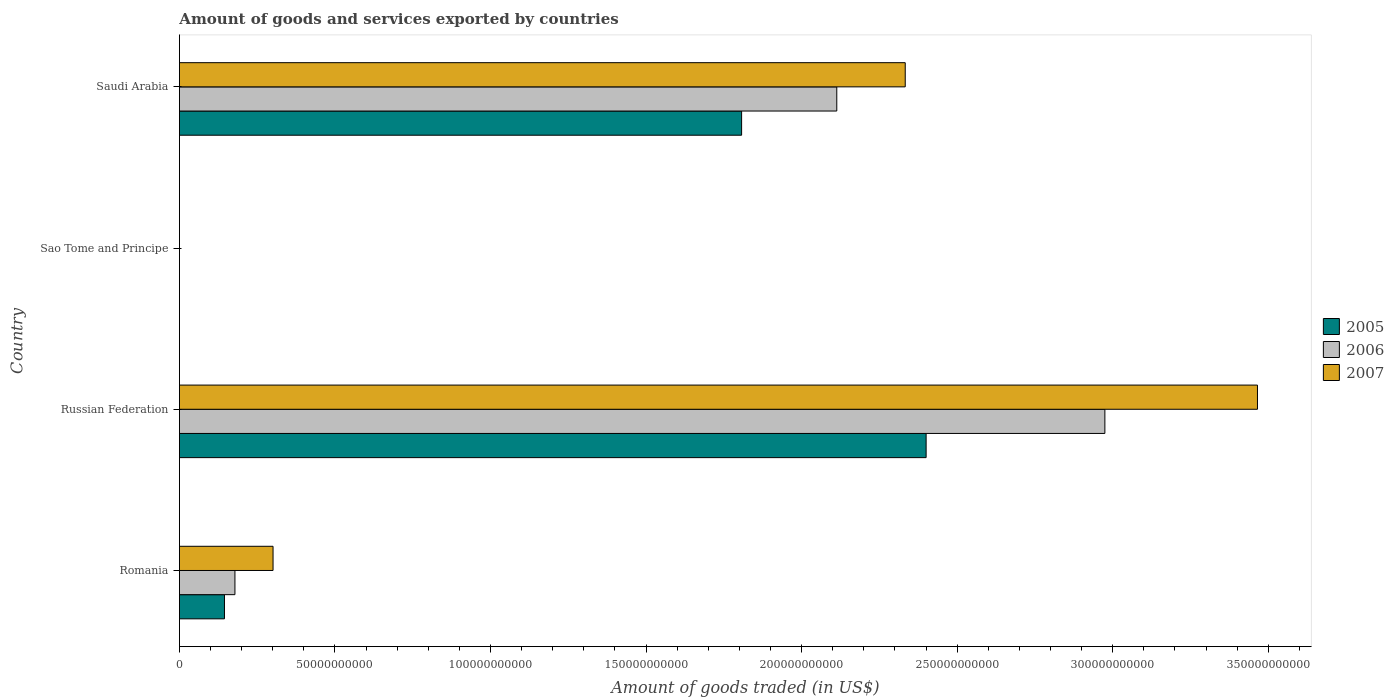How many different coloured bars are there?
Your response must be concise. 3. How many groups of bars are there?
Your answer should be compact. 4. Are the number of bars per tick equal to the number of legend labels?
Offer a terse response. Yes. How many bars are there on the 4th tick from the bottom?
Provide a short and direct response. 3. What is the label of the 2nd group of bars from the top?
Keep it short and to the point. Sao Tome and Principe. What is the total amount of goods and services exported in 2006 in Russian Federation?
Your answer should be very brief. 2.97e+11. Across all countries, what is the maximum total amount of goods and services exported in 2006?
Your response must be concise. 2.97e+11. Across all countries, what is the minimum total amount of goods and services exported in 2006?
Provide a short and direct response. 7.71e+06. In which country was the total amount of goods and services exported in 2006 maximum?
Your response must be concise. Russian Federation. In which country was the total amount of goods and services exported in 2007 minimum?
Offer a terse response. Sao Tome and Principe. What is the total total amount of goods and services exported in 2006 in the graph?
Your response must be concise. 5.27e+11. What is the difference between the total amount of goods and services exported in 2006 in Russian Federation and that in Sao Tome and Principe?
Your answer should be compact. 2.97e+11. What is the difference between the total amount of goods and services exported in 2006 in Saudi Arabia and the total amount of goods and services exported in 2007 in Romania?
Offer a terse response. 1.81e+11. What is the average total amount of goods and services exported in 2006 per country?
Offer a terse response. 1.32e+11. What is the difference between the total amount of goods and services exported in 2006 and total amount of goods and services exported in 2007 in Russian Federation?
Provide a succinct answer. -4.90e+1. What is the ratio of the total amount of goods and services exported in 2005 in Romania to that in Sao Tome and Principe?
Your answer should be very brief. 2132.94. Is the total amount of goods and services exported in 2006 in Romania less than that in Russian Federation?
Your response must be concise. Yes. What is the difference between the highest and the second highest total amount of goods and services exported in 2006?
Make the answer very short. 8.62e+1. What is the difference between the highest and the lowest total amount of goods and services exported in 2006?
Give a very brief answer. 2.97e+11. In how many countries, is the total amount of goods and services exported in 2007 greater than the average total amount of goods and services exported in 2007 taken over all countries?
Offer a very short reply. 2. Is it the case that in every country, the sum of the total amount of goods and services exported in 2007 and total amount of goods and services exported in 2006 is greater than the total amount of goods and services exported in 2005?
Provide a succinct answer. Yes. What is the difference between two consecutive major ticks on the X-axis?
Provide a short and direct response. 5.00e+1. Does the graph contain grids?
Offer a very short reply. No. Where does the legend appear in the graph?
Make the answer very short. Center right. What is the title of the graph?
Ensure brevity in your answer.  Amount of goods and services exported by countries. What is the label or title of the X-axis?
Offer a terse response. Amount of goods traded (in US$). What is the Amount of goods traded (in US$) of 2005 in Romania?
Provide a succinct answer. 1.45e+1. What is the Amount of goods traded (in US$) of 2006 in Romania?
Offer a very short reply. 1.78e+1. What is the Amount of goods traded (in US$) in 2007 in Romania?
Offer a very short reply. 3.01e+1. What is the Amount of goods traded (in US$) in 2005 in Russian Federation?
Keep it short and to the point. 2.40e+11. What is the Amount of goods traded (in US$) of 2006 in Russian Federation?
Provide a short and direct response. 2.97e+11. What is the Amount of goods traded (in US$) of 2007 in Russian Federation?
Provide a short and direct response. 3.47e+11. What is the Amount of goods traded (in US$) in 2005 in Sao Tome and Principe?
Your answer should be compact. 6.79e+06. What is the Amount of goods traded (in US$) of 2006 in Sao Tome and Principe?
Provide a succinct answer. 7.71e+06. What is the Amount of goods traded (in US$) in 2007 in Sao Tome and Principe?
Give a very brief answer. 6.81e+06. What is the Amount of goods traded (in US$) of 2005 in Saudi Arabia?
Offer a terse response. 1.81e+11. What is the Amount of goods traded (in US$) in 2006 in Saudi Arabia?
Keep it short and to the point. 2.11e+11. What is the Amount of goods traded (in US$) in 2007 in Saudi Arabia?
Make the answer very short. 2.33e+11. Across all countries, what is the maximum Amount of goods traded (in US$) of 2005?
Give a very brief answer. 2.40e+11. Across all countries, what is the maximum Amount of goods traded (in US$) of 2006?
Make the answer very short. 2.97e+11. Across all countries, what is the maximum Amount of goods traded (in US$) in 2007?
Provide a succinct answer. 3.47e+11. Across all countries, what is the minimum Amount of goods traded (in US$) in 2005?
Make the answer very short. 6.79e+06. Across all countries, what is the minimum Amount of goods traded (in US$) of 2006?
Provide a succinct answer. 7.71e+06. Across all countries, what is the minimum Amount of goods traded (in US$) in 2007?
Keep it short and to the point. 6.81e+06. What is the total Amount of goods traded (in US$) in 2005 in the graph?
Offer a very short reply. 4.35e+11. What is the total Amount of goods traded (in US$) of 2006 in the graph?
Give a very brief answer. 5.27e+11. What is the total Amount of goods traded (in US$) in 2007 in the graph?
Make the answer very short. 6.10e+11. What is the difference between the Amount of goods traded (in US$) of 2005 in Romania and that in Russian Federation?
Provide a succinct answer. -2.26e+11. What is the difference between the Amount of goods traded (in US$) in 2006 in Romania and that in Russian Federation?
Provide a succinct answer. -2.80e+11. What is the difference between the Amount of goods traded (in US$) of 2007 in Romania and that in Russian Federation?
Provide a short and direct response. -3.16e+11. What is the difference between the Amount of goods traded (in US$) of 2005 in Romania and that in Sao Tome and Principe?
Make the answer very short. 1.45e+1. What is the difference between the Amount of goods traded (in US$) in 2006 in Romania and that in Sao Tome and Principe?
Provide a succinct answer. 1.78e+1. What is the difference between the Amount of goods traded (in US$) of 2007 in Romania and that in Sao Tome and Principe?
Provide a short and direct response. 3.01e+1. What is the difference between the Amount of goods traded (in US$) in 2005 in Romania and that in Saudi Arabia?
Your answer should be compact. -1.66e+11. What is the difference between the Amount of goods traded (in US$) of 2006 in Romania and that in Saudi Arabia?
Give a very brief answer. -1.93e+11. What is the difference between the Amount of goods traded (in US$) in 2007 in Romania and that in Saudi Arabia?
Offer a very short reply. -2.03e+11. What is the difference between the Amount of goods traded (in US$) of 2005 in Russian Federation and that in Sao Tome and Principe?
Keep it short and to the point. 2.40e+11. What is the difference between the Amount of goods traded (in US$) of 2006 in Russian Federation and that in Sao Tome and Principe?
Ensure brevity in your answer.  2.97e+11. What is the difference between the Amount of goods traded (in US$) in 2007 in Russian Federation and that in Sao Tome and Principe?
Keep it short and to the point. 3.47e+11. What is the difference between the Amount of goods traded (in US$) in 2005 in Russian Federation and that in Saudi Arabia?
Provide a short and direct response. 5.93e+1. What is the difference between the Amount of goods traded (in US$) of 2006 in Russian Federation and that in Saudi Arabia?
Ensure brevity in your answer.  8.62e+1. What is the difference between the Amount of goods traded (in US$) in 2007 in Russian Federation and that in Saudi Arabia?
Provide a short and direct response. 1.13e+11. What is the difference between the Amount of goods traded (in US$) of 2005 in Sao Tome and Principe and that in Saudi Arabia?
Offer a very short reply. -1.81e+11. What is the difference between the Amount of goods traded (in US$) in 2006 in Sao Tome and Principe and that in Saudi Arabia?
Your answer should be compact. -2.11e+11. What is the difference between the Amount of goods traded (in US$) of 2007 in Sao Tome and Principe and that in Saudi Arabia?
Ensure brevity in your answer.  -2.33e+11. What is the difference between the Amount of goods traded (in US$) of 2005 in Romania and the Amount of goods traded (in US$) of 2006 in Russian Federation?
Make the answer very short. -2.83e+11. What is the difference between the Amount of goods traded (in US$) in 2005 in Romania and the Amount of goods traded (in US$) in 2007 in Russian Federation?
Your answer should be compact. -3.32e+11. What is the difference between the Amount of goods traded (in US$) of 2006 in Romania and the Amount of goods traded (in US$) of 2007 in Russian Federation?
Make the answer very short. -3.29e+11. What is the difference between the Amount of goods traded (in US$) in 2005 in Romania and the Amount of goods traded (in US$) in 2006 in Sao Tome and Principe?
Keep it short and to the point. 1.45e+1. What is the difference between the Amount of goods traded (in US$) in 2005 in Romania and the Amount of goods traded (in US$) in 2007 in Sao Tome and Principe?
Provide a succinct answer. 1.45e+1. What is the difference between the Amount of goods traded (in US$) of 2006 in Romania and the Amount of goods traded (in US$) of 2007 in Sao Tome and Principe?
Offer a very short reply. 1.78e+1. What is the difference between the Amount of goods traded (in US$) in 2005 in Romania and the Amount of goods traded (in US$) in 2006 in Saudi Arabia?
Provide a succinct answer. -1.97e+11. What is the difference between the Amount of goods traded (in US$) in 2005 in Romania and the Amount of goods traded (in US$) in 2007 in Saudi Arabia?
Keep it short and to the point. -2.19e+11. What is the difference between the Amount of goods traded (in US$) in 2006 in Romania and the Amount of goods traded (in US$) in 2007 in Saudi Arabia?
Make the answer very short. -2.15e+11. What is the difference between the Amount of goods traded (in US$) in 2005 in Russian Federation and the Amount of goods traded (in US$) in 2006 in Sao Tome and Principe?
Provide a short and direct response. 2.40e+11. What is the difference between the Amount of goods traded (in US$) of 2005 in Russian Federation and the Amount of goods traded (in US$) of 2007 in Sao Tome and Principe?
Keep it short and to the point. 2.40e+11. What is the difference between the Amount of goods traded (in US$) of 2006 in Russian Federation and the Amount of goods traded (in US$) of 2007 in Sao Tome and Principe?
Provide a succinct answer. 2.97e+11. What is the difference between the Amount of goods traded (in US$) in 2005 in Russian Federation and the Amount of goods traded (in US$) in 2006 in Saudi Arabia?
Ensure brevity in your answer.  2.87e+1. What is the difference between the Amount of goods traded (in US$) in 2005 in Russian Federation and the Amount of goods traded (in US$) in 2007 in Saudi Arabia?
Provide a succinct answer. 6.71e+09. What is the difference between the Amount of goods traded (in US$) in 2006 in Russian Federation and the Amount of goods traded (in US$) in 2007 in Saudi Arabia?
Offer a very short reply. 6.42e+1. What is the difference between the Amount of goods traded (in US$) in 2005 in Sao Tome and Principe and the Amount of goods traded (in US$) in 2006 in Saudi Arabia?
Ensure brevity in your answer.  -2.11e+11. What is the difference between the Amount of goods traded (in US$) in 2005 in Sao Tome and Principe and the Amount of goods traded (in US$) in 2007 in Saudi Arabia?
Your answer should be very brief. -2.33e+11. What is the difference between the Amount of goods traded (in US$) of 2006 in Sao Tome and Principe and the Amount of goods traded (in US$) of 2007 in Saudi Arabia?
Offer a terse response. -2.33e+11. What is the average Amount of goods traded (in US$) of 2005 per country?
Make the answer very short. 1.09e+11. What is the average Amount of goods traded (in US$) in 2006 per country?
Offer a terse response. 1.32e+11. What is the average Amount of goods traded (in US$) in 2007 per country?
Your answer should be compact. 1.52e+11. What is the difference between the Amount of goods traded (in US$) of 2005 and Amount of goods traded (in US$) of 2006 in Romania?
Keep it short and to the point. -3.36e+09. What is the difference between the Amount of goods traded (in US$) of 2005 and Amount of goods traded (in US$) of 2007 in Romania?
Ensure brevity in your answer.  -1.56e+1. What is the difference between the Amount of goods traded (in US$) of 2006 and Amount of goods traded (in US$) of 2007 in Romania?
Your response must be concise. -1.23e+1. What is the difference between the Amount of goods traded (in US$) in 2005 and Amount of goods traded (in US$) in 2006 in Russian Federation?
Make the answer very short. -5.75e+1. What is the difference between the Amount of goods traded (in US$) of 2005 and Amount of goods traded (in US$) of 2007 in Russian Federation?
Your response must be concise. -1.07e+11. What is the difference between the Amount of goods traded (in US$) in 2006 and Amount of goods traded (in US$) in 2007 in Russian Federation?
Provide a succinct answer. -4.90e+1. What is the difference between the Amount of goods traded (in US$) of 2005 and Amount of goods traded (in US$) of 2006 in Sao Tome and Principe?
Provide a succinct answer. -9.20e+05. What is the difference between the Amount of goods traded (in US$) of 2005 and Amount of goods traded (in US$) of 2007 in Sao Tome and Principe?
Provide a short and direct response. -1.96e+04. What is the difference between the Amount of goods traded (in US$) in 2006 and Amount of goods traded (in US$) in 2007 in Sao Tome and Principe?
Give a very brief answer. 9.00e+05. What is the difference between the Amount of goods traded (in US$) in 2005 and Amount of goods traded (in US$) in 2006 in Saudi Arabia?
Offer a very short reply. -3.06e+1. What is the difference between the Amount of goods traded (in US$) in 2005 and Amount of goods traded (in US$) in 2007 in Saudi Arabia?
Your answer should be compact. -5.26e+1. What is the difference between the Amount of goods traded (in US$) in 2006 and Amount of goods traded (in US$) in 2007 in Saudi Arabia?
Your response must be concise. -2.20e+1. What is the ratio of the Amount of goods traded (in US$) in 2005 in Romania to that in Russian Federation?
Ensure brevity in your answer.  0.06. What is the ratio of the Amount of goods traded (in US$) of 2007 in Romania to that in Russian Federation?
Ensure brevity in your answer.  0.09. What is the ratio of the Amount of goods traded (in US$) in 2005 in Romania to that in Sao Tome and Principe?
Provide a short and direct response. 2132.94. What is the ratio of the Amount of goods traded (in US$) in 2006 in Romania to that in Sao Tome and Principe?
Your answer should be compact. 2314.31. What is the ratio of the Amount of goods traded (in US$) of 2007 in Romania to that in Sao Tome and Principe?
Your answer should be very brief. 4419.4. What is the ratio of the Amount of goods traded (in US$) of 2005 in Romania to that in Saudi Arabia?
Provide a succinct answer. 0.08. What is the ratio of the Amount of goods traded (in US$) of 2006 in Romania to that in Saudi Arabia?
Provide a succinct answer. 0.08. What is the ratio of the Amount of goods traded (in US$) in 2007 in Romania to that in Saudi Arabia?
Keep it short and to the point. 0.13. What is the ratio of the Amount of goods traded (in US$) of 2005 in Russian Federation to that in Sao Tome and Principe?
Offer a very short reply. 3.53e+04. What is the ratio of the Amount of goods traded (in US$) in 2006 in Russian Federation to that in Sao Tome and Principe?
Provide a succinct answer. 3.86e+04. What is the ratio of the Amount of goods traded (in US$) in 2007 in Russian Federation to that in Sao Tome and Principe?
Offer a very short reply. 5.09e+04. What is the ratio of the Amount of goods traded (in US$) in 2005 in Russian Federation to that in Saudi Arabia?
Your answer should be compact. 1.33. What is the ratio of the Amount of goods traded (in US$) in 2006 in Russian Federation to that in Saudi Arabia?
Ensure brevity in your answer.  1.41. What is the ratio of the Amount of goods traded (in US$) in 2007 in Russian Federation to that in Saudi Arabia?
Your answer should be very brief. 1.49. What is the ratio of the Amount of goods traded (in US$) of 2006 in Sao Tome and Principe to that in Saudi Arabia?
Your response must be concise. 0. What is the ratio of the Amount of goods traded (in US$) of 2007 in Sao Tome and Principe to that in Saudi Arabia?
Provide a succinct answer. 0. What is the difference between the highest and the second highest Amount of goods traded (in US$) in 2005?
Make the answer very short. 5.93e+1. What is the difference between the highest and the second highest Amount of goods traded (in US$) in 2006?
Your response must be concise. 8.62e+1. What is the difference between the highest and the second highest Amount of goods traded (in US$) of 2007?
Offer a terse response. 1.13e+11. What is the difference between the highest and the lowest Amount of goods traded (in US$) of 2005?
Offer a terse response. 2.40e+11. What is the difference between the highest and the lowest Amount of goods traded (in US$) of 2006?
Your response must be concise. 2.97e+11. What is the difference between the highest and the lowest Amount of goods traded (in US$) of 2007?
Your answer should be very brief. 3.47e+11. 